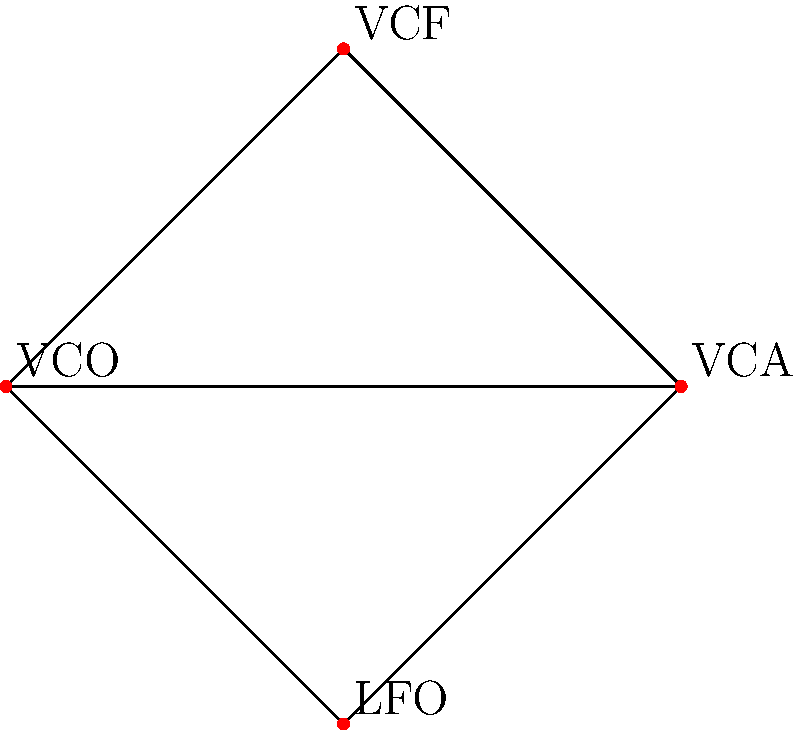In this modular synthesizer patch diagram, each module represents an element of a group, and connections represent compositions. If we define the identity element as "no effect" and assume all connections are reversible, how many unique elements are in the group generated by these four modules? Let's approach this step-by-step:

1. We have four modules: VCO, VCF, VCA, and LFO.

2. In group theory, we need to consider all possible combinations of these elements, including the identity element.

3. The possible elements are:
   - Identity (no effect)
   - Individual modules: VCO, VCF, VCA, LFO
   - Combinations of two modules: VCO-VCF, VCO-VCA, VCO-LFO, VCF-VCA, VCF-LFO, VCA-LFO
   - Combinations of three modules: VCO-VCF-VCA, VCO-VCF-LFO, VCO-VCA-LFO, VCF-VCA-LFO
   - Combination of all four modules: VCO-VCF-VCA-LFO

4. We assume all connections are reversible, which means each combination is its own inverse when applied twice.

5. Counting these up:
   - 1 identity element
   - 4 individual modules
   - 6 combinations of two modules
   - 4 combinations of three modules
   - 1 combination of all four modules

6. The total number of unique elements is the sum of all these: 1 + 4 + 6 + 4 + 1 = 16

Therefore, the group generated by these four modules has 16 unique elements.
Answer: 16 